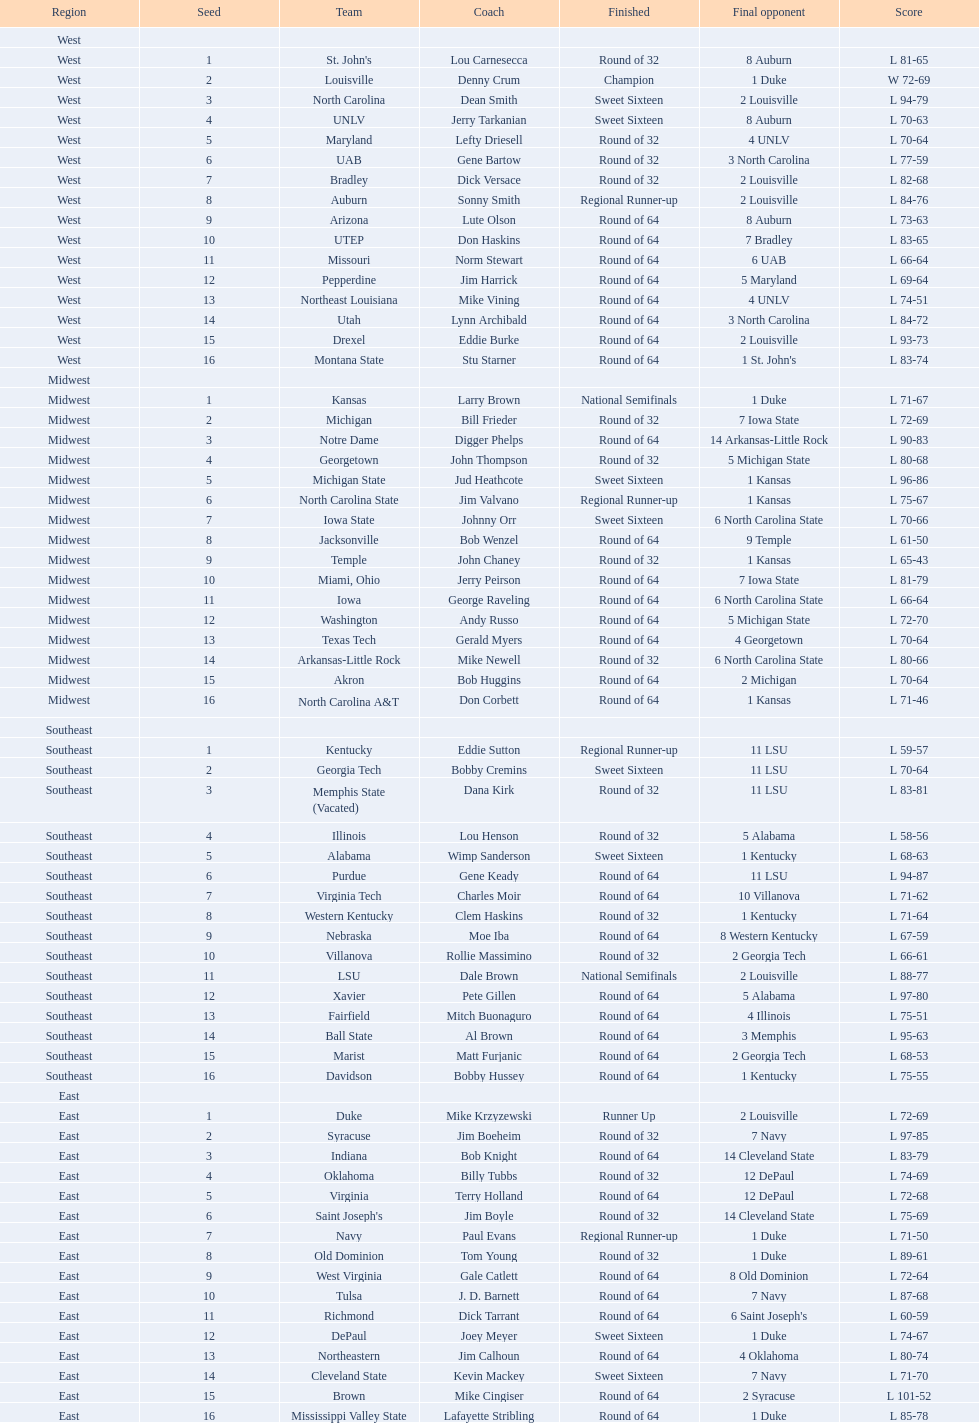North carolina and unlv each made it to which round? Sweet Sixteen. 